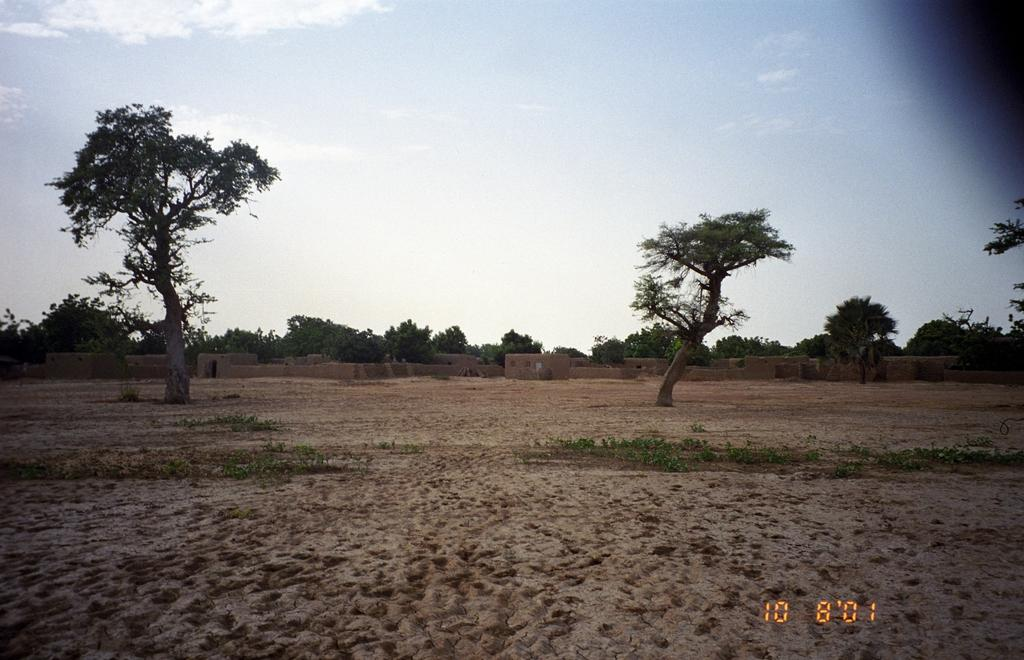What can be found in the bottom left corner of the image? There is a watermark on the bottom left of the image. What type of vegetation is visible in the background of the image? There are two trees in the background of the image. How would you describe the ground in the background of the image? The ground in the background appears dry. What type of structure is visible in the background of the image? There is a wall in the background of the image. What can be seen in the sky in the background of the image? There are clouds in the blue sky in the background of the image. What type of experience does the mother have with the burst pipe in the image? There is no mother, burst pipe, or any indication of a plumbing issue in the image. 